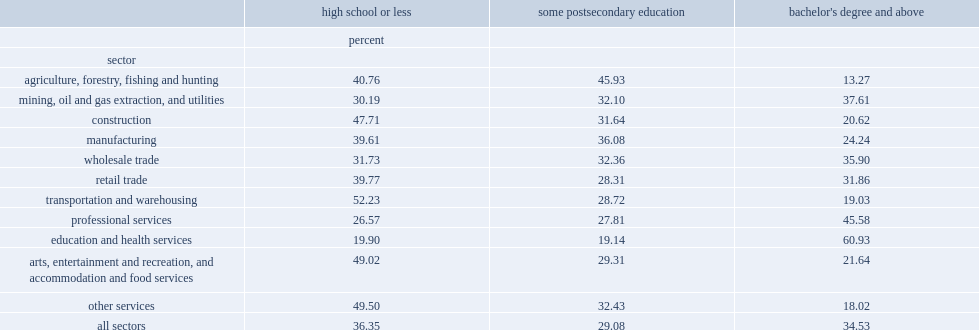What was the percentage of people having a high school education or less for all sectors? 36.35. What was the percentage of people having bachelor's degree or above upon landing for all sectors? 34.53. What level of education of owners made up the largest share in construction; manufacturing; retail trade; transportation; arts, accommodation and food services; and other services? High school or less. What level of education of owners represented the largest share in mining and utilities, wholesale trade, professional services, and education and health? Bachelor's degree and above. 